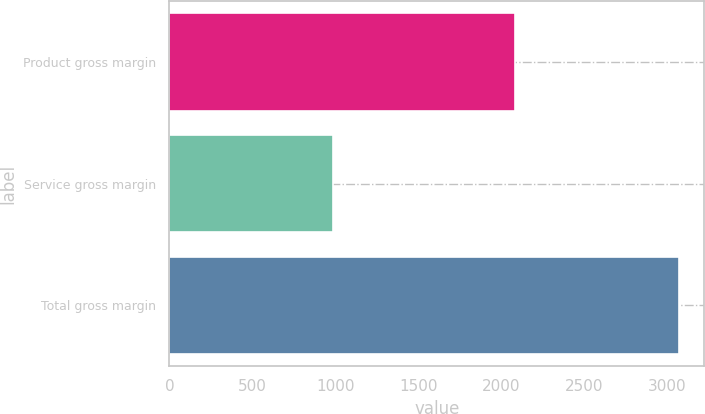<chart> <loc_0><loc_0><loc_500><loc_500><bar_chart><fcel>Product gross margin<fcel>Service gross margin<fcel>Total gross margin<nl><fcel>2085.3<fcel>986.8<fcel>3072.1<nl></chart> 